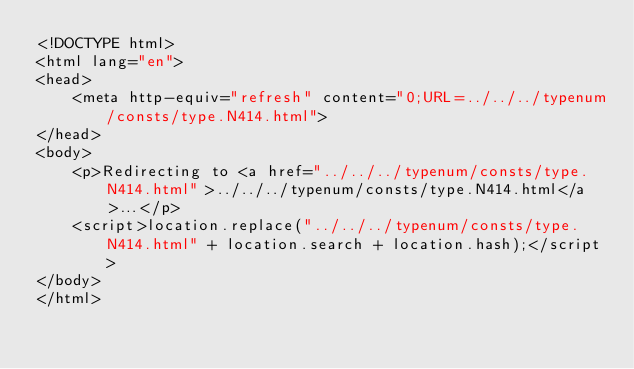Convert code to text. <code><loc_0><loc_0><loc_500><loc_500><_HTML_><!DOCTYPE html>
<html lang="en">
<head>
    <meta http-equiv="refresh" content="0;URL=../../../typenum/consts/type.N414.html">
</head>
<body>
    <p>Redirecting to <a href="../../../typenum/consts/type.N414.html">../../../typenum/consts/type.N414.html</a>...</p>
    <script>location.replace("../../../typenum/consts/type.N414.html" + location.search + location.hash);</script>
</body>
</html></code> 